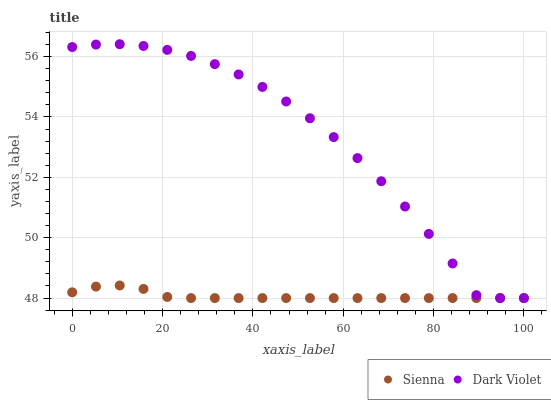Does Sienna have the minimum area under the curve?
Answer yes or no. Yes. Does Dark Violet have the maximum area under the curve?
Answer yes or no. Yes. Does Dark Violet have the minimum area under the curve?
Answer yes or no. No. Is Sienna the smoothest?
Answer yes or no. Yes. Is Dark Violet the roughest?
Answer yes or no. Yes. Is Dark Violet the smoothest?
Answer yes or no. No. Does Sienna have the lowest value?
Answer yes or no. Yes. Does Dark Violet have the highest value?
Answer yes or no. Yes. Does Dark Violet intersect Sienna?
Answer yes or no. Yes. Is Dark Violet less than Sienna?
Answer yes or no. No. Is Dark Violet greater than Sienna?
Answer yes or no. No. 